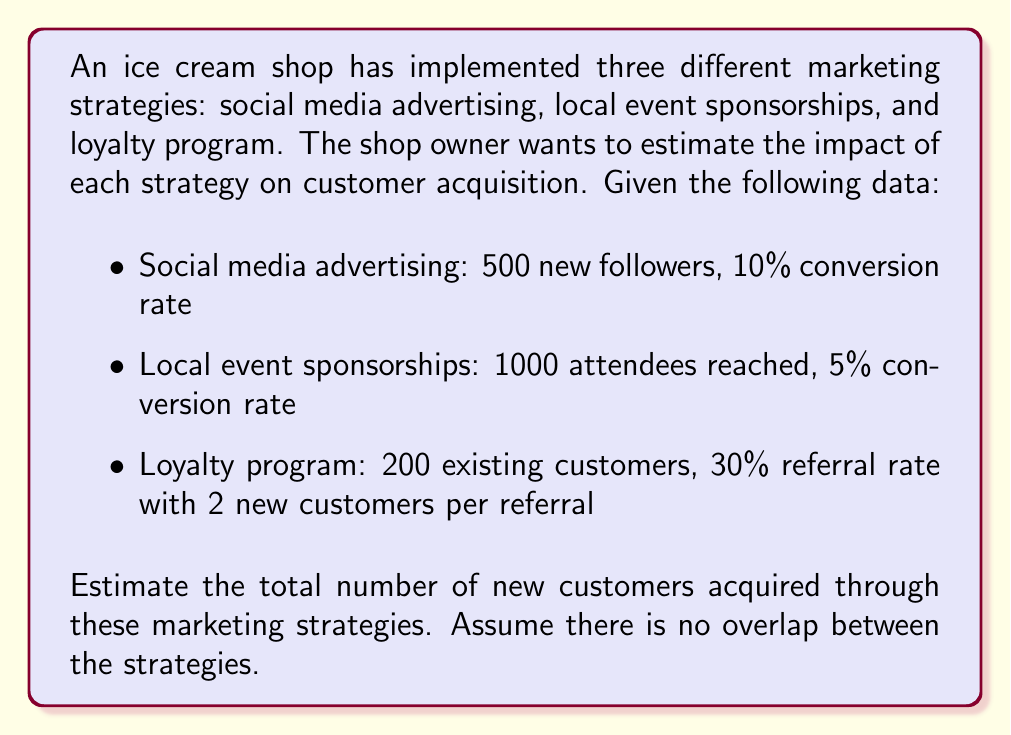Teach me how to tackle this problem. Let's break down the problem and calculate the number of new customers acquired through each strategy:

1. Social media advertising:
   - Number of new followers: 500
   - Conversion rate: 10%
   - New customers = $500 \times 0.10 = 50$

2. Local event sponsorships:
   - Number of attendees reached: 1000
   - Conversion rate: 5%
   - New customers = $1000 \times 0.05 = 50$

3. Loyalty program:
   - Number of existing customers: 200
   - Referral rate: 30%
   - New customers per referral: 2
   - New customers = $200 \times 0.30 \times 2 = 120$

To estimate the total number of new customers acquired, we sum up the results from all three strategies:

$$ \text{Total new customers} = 50 + 50 + 120 = 220 $$

Therefore, the estimated total number of new customers acquired through these marketing strategies is 220.
Answer: 220 new customers 